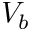Convert formula to latex. <formula><loc_0><loc_0><loc_500><loc_500>V _ { b }</formula> 